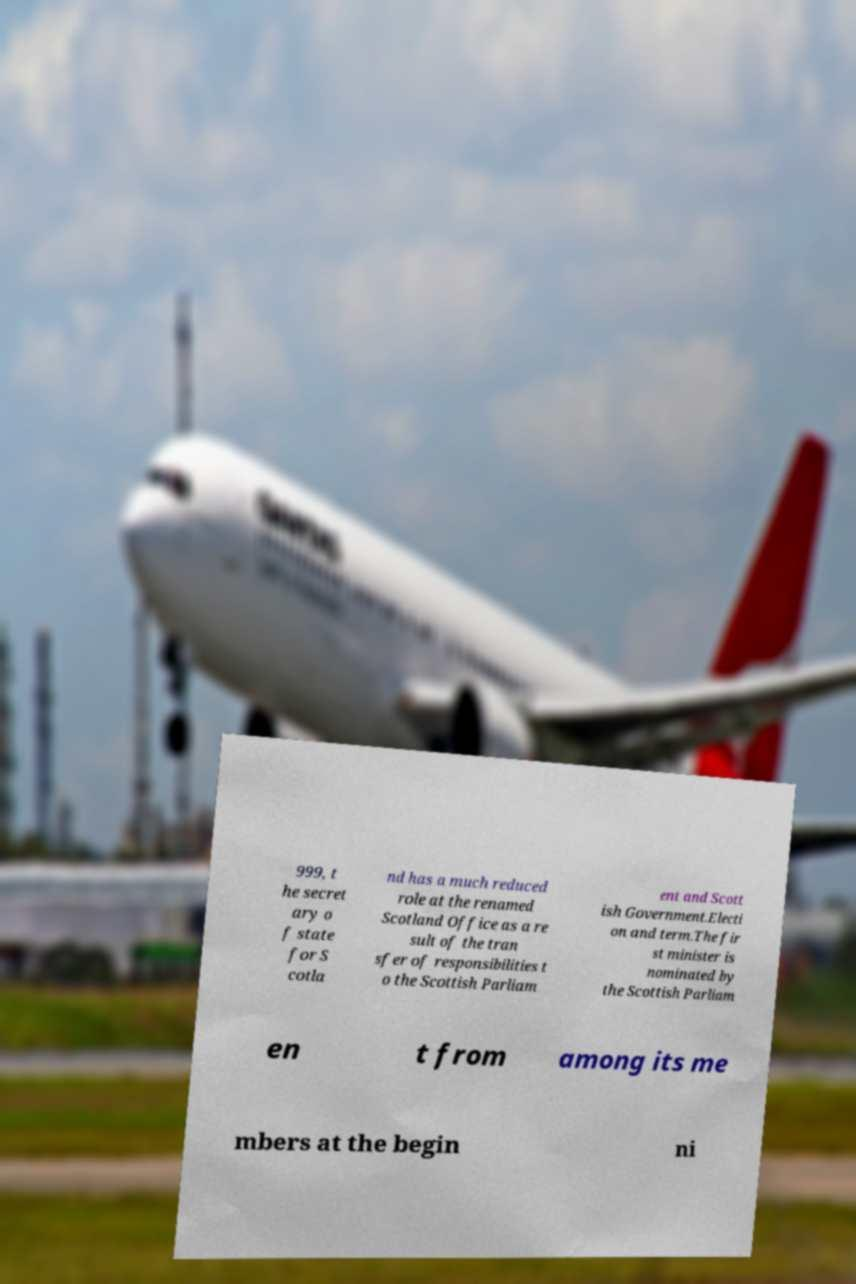I need the written content from this picture converted into text. Can you do that? 999, t he secret ary o f state for S cotla nd has a much reduced role at the renamed Scotland Office as a re sult of the tran sfer of responsibilities t o the Scottish Parliam ent and Scott ish Government.Electi on and term.The fir st minister is nominated by the Scottish Parliam en t from among its me mbers at the begin ni 